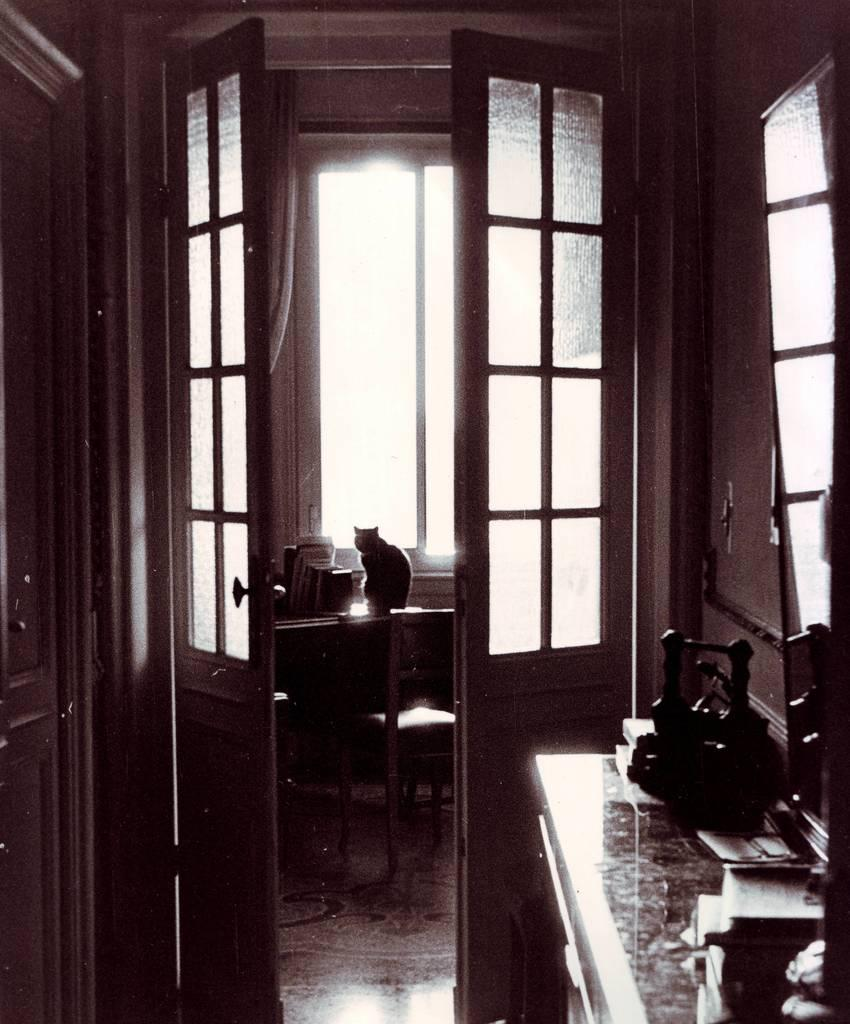What animal is sitting on the table in the image? There is a cat sitting on the table in the image. What type of furniture is visible in the image? There are chairs in the image. What feature do the doors in the image have? The doors in the image have glass. What direction is the question being transported in the image? There is no question or transportation present in the image. 